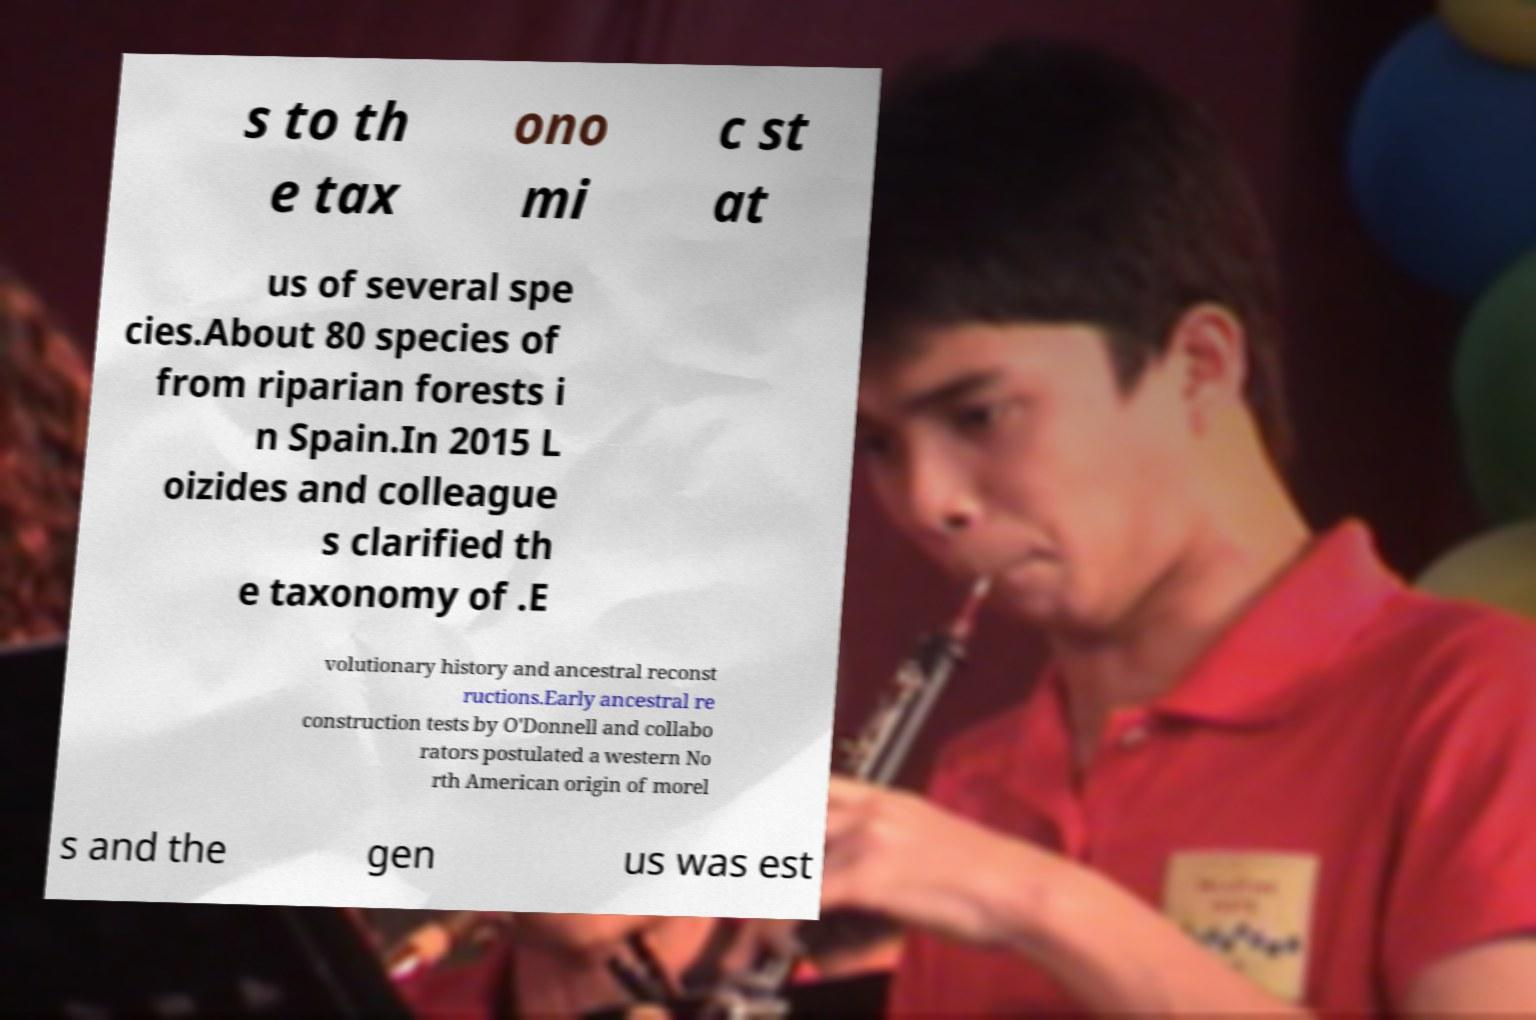There's text embedded in this image that I need extracted. Can you transcribe it verbatim? s to th e tax ono mi c st at us of several spe cies.About 80 species of from riparian forests i n Spain.In 2015 L oizides and colleague s clarified th e taxonomy of .E volutionary history and ancestral reconst ructions.Early ancestral re construction tests by O'Donnell and collabo rators postulated a western No rth American origin of morel s and the gen us was est 